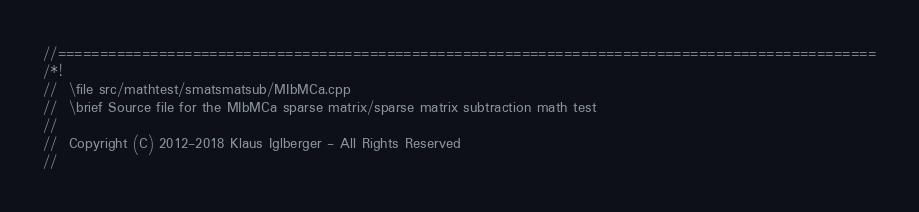Convert code to text. <code><loc_0><loc_0><loc_500><loc_500><_C++_>//=================================================================================================
/*!
//  \file src/mathtest/smatsmatsub/MIbMCa.cpp
//  \brief Source file for the MIbMCa sparse matrix/sparse matrix subtraction math test
//
//  Copyright (C) 2012-2018 Klaus Iglberger - All Rights Reserved
//</code> 